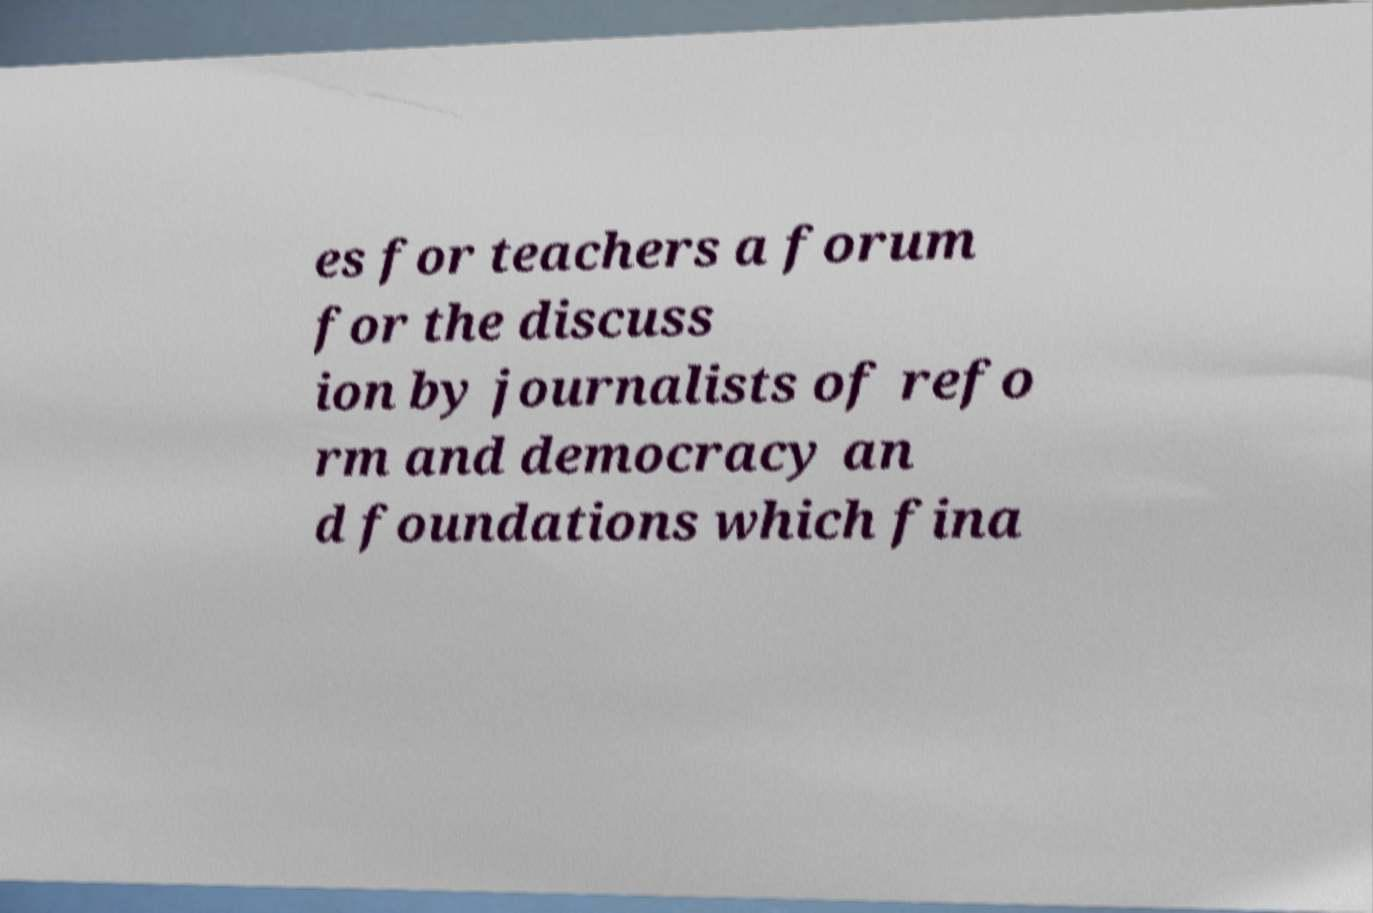What messages or text are displayed in this image? I need them in a readable, typed format. es for teachers a forum for the discuss ion by journalists of refo rm and democracy an d foundations which fina 